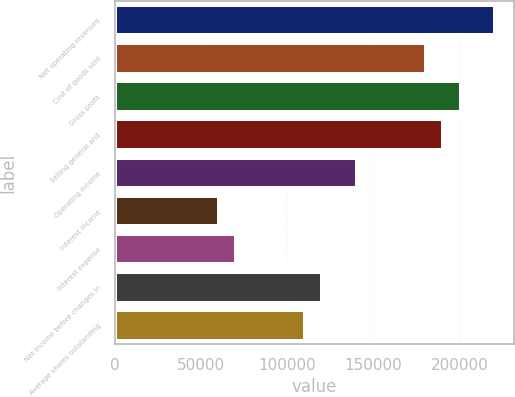Convert chart to OTSL. <chart><loc_0><loc_0><loc_500><loc_500><bar_chart><fcel>Net operating revenues<fcel>Cost of goods sold<fcel>Gross profit<fcel>Selling general and<fcel>Operating income<fcel>Interest income<fcel>Interest expense<fcel>Net income before changes in<fcel>Average shares outstanding<nl><fcel>220714<fcel>180584<fcel>200649<fcel>190617<fcel>140455<fcel>60195.4<fcel>70227.8<fcel>120390<fcel>110357<nl></chart> 